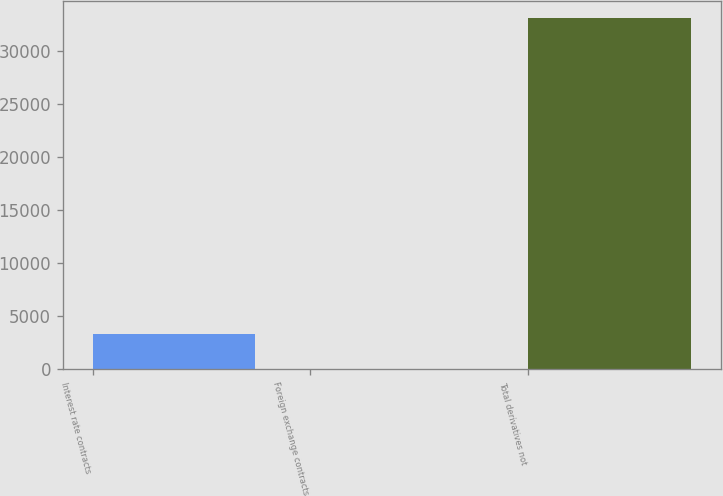Convert chart to OTSL. <chart><loc_0><loc_0><loc_500><loc_500><bar_chart><fcel>Interest rate contracts<fcel>Foreign exchange contracts<fcel>Total derivatives not<nl><fcel>3332<fcel>23<fcel>33113<nl></chart> 